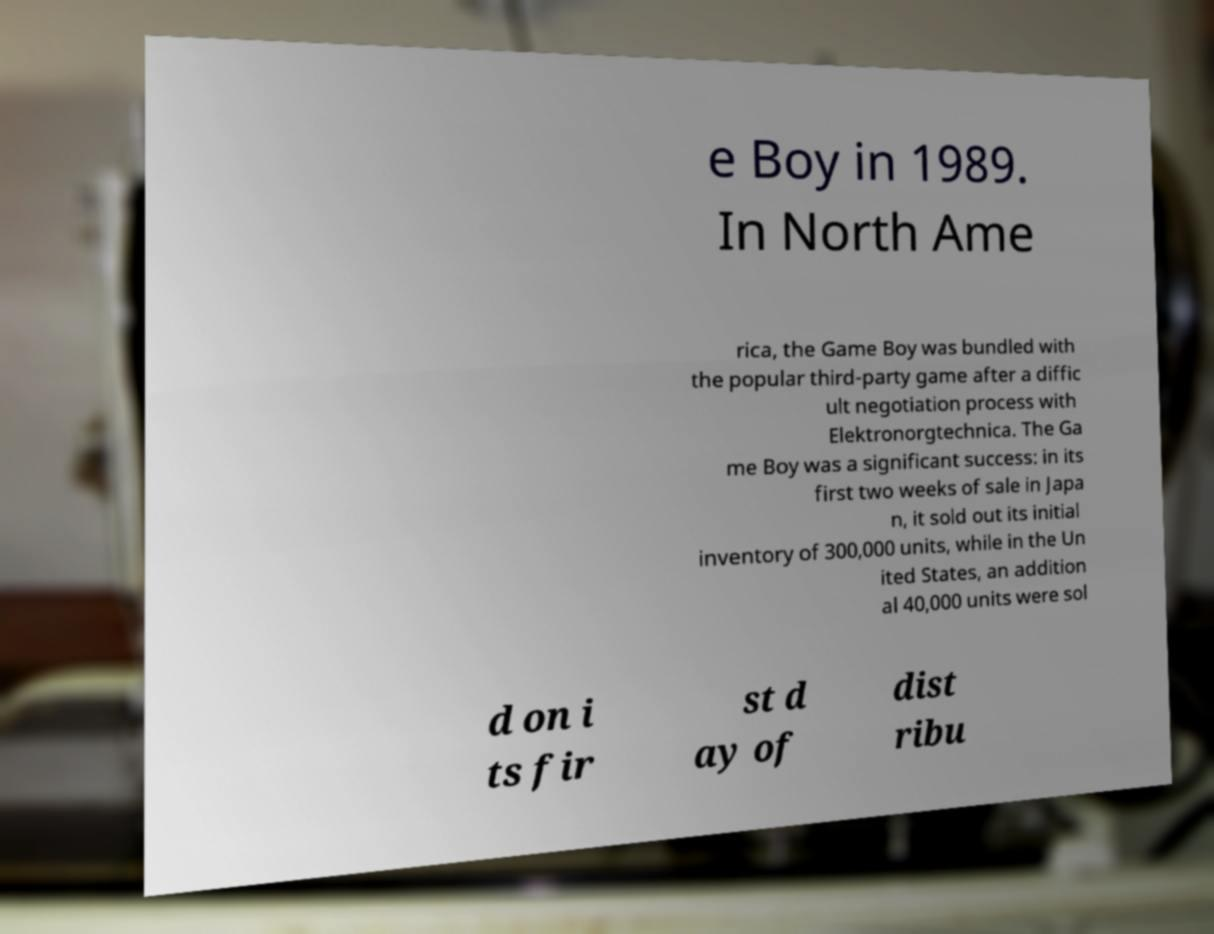Please read and relay the text visible in this image. What does it say? e Boy in 1989. In North Ame rica, the Game Boy was bundled with the popular third-party game after a diffic ult negotiation process with Elektronorgtechnica. The Ga me Boy was a significant success: in its first two weeks of sale in Japa n, it sold out its initial inventory of 300,000 units, while in the Un ited States, an addition al 40,000 units were sol d on i ts fir st d ay of dist ribu 